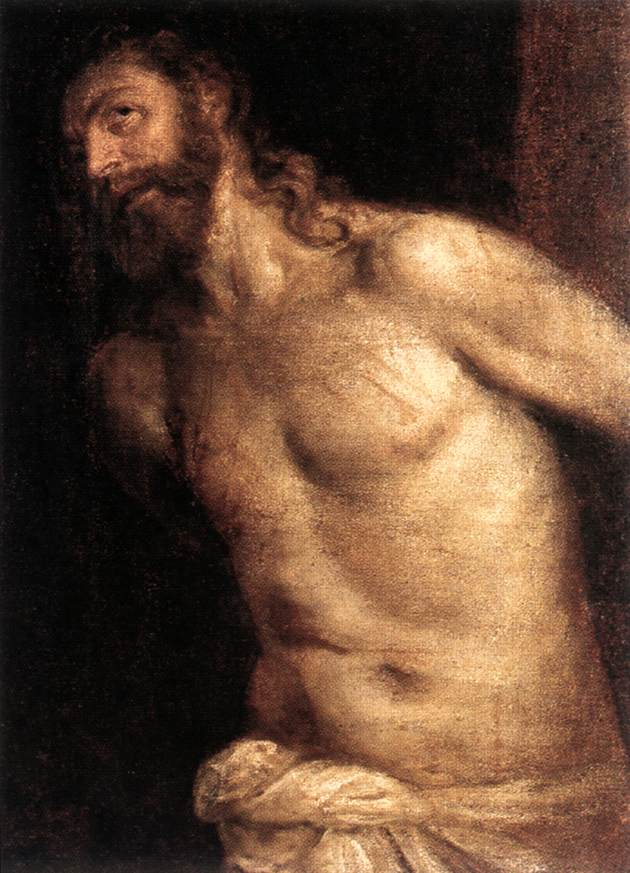What are the key elements in this picture? The image depicts a bearded man with long hair, who might be a biblical figure, as suggested by his serene yet pained expression and classical, idealized physique. Painted in a Baroque style, the artwork captures a moment full of emotional depth and realism. The man is shown from the waist up, his muscular torso bare, with a worn white cloth draped loosely over his lower body. The background is dark and indistinct, which creates a powerful contrast, drawing attention to the illuminated figure. This use of chiaroscuro, the interplay of light and shadow, is a hallmark of Baroque art, enhancing the dramatic effect. The earthy color palette, dominated by warm browns and muted whites, adds to the painting’s somber yet captivating mood. The meticulous rendering of the figure’s form, combined with the dynamic use of light, gives the painting a three-dimensional quality that invites the viewer into a moment suspended in time. 